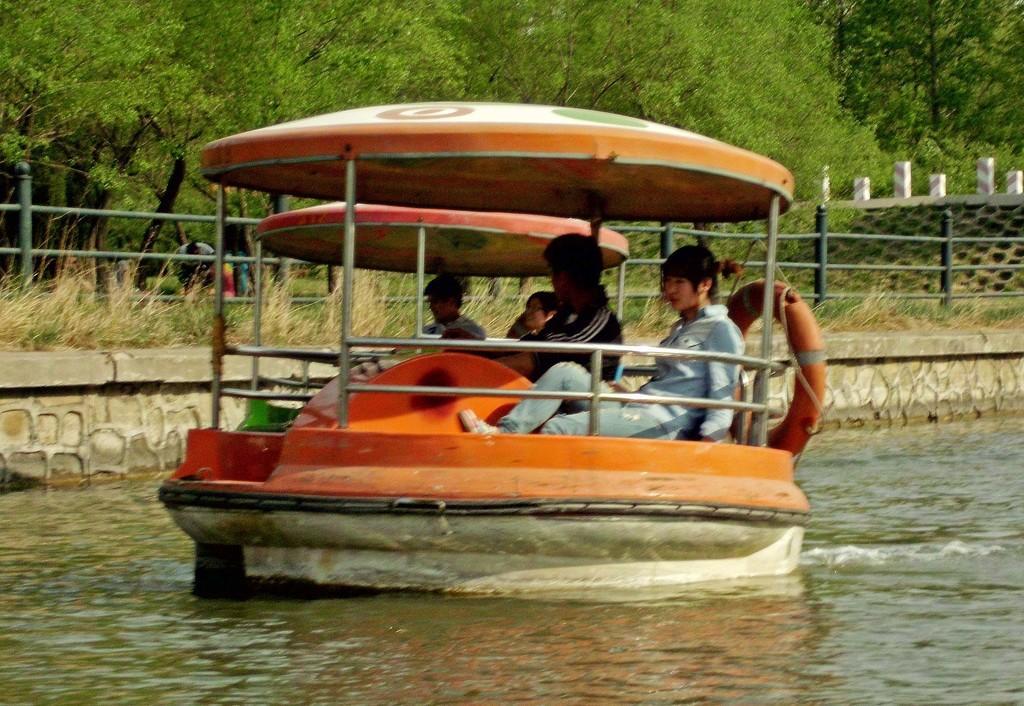Could you give a brief overview of what you see in this image? There are few people sitting on the boats. On the boat there is a tube. And the boat is on the water. In the back there is a railing, grass and trees. 